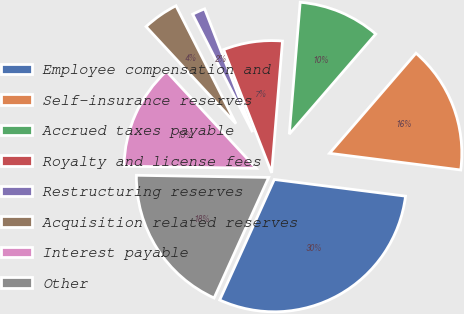<chart> <loc_0><loc_0><loc_500><loc_500><pie_chart><fcel>Employee compensation and<fcel>Self-insurance reserves<fcel>Accrued taxes payable<fcel>Royalty and license fees<fcel>Restructuring reserves<fcel>Acquisition related reserves<fcel>Interest payable<fcel>Other<nl><fcel>29.76%<fcel>15.67%<fcel>10.03%<fcel>7.22%<fcel>1.58%<fcel>4.4%<fcel>12.85%<fcel>18.49%<nl></chart> 